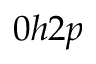Convert formula to latex. <formula><loc_0><loc_0><loc_500><loc_500>0 h 2 p</formula> 